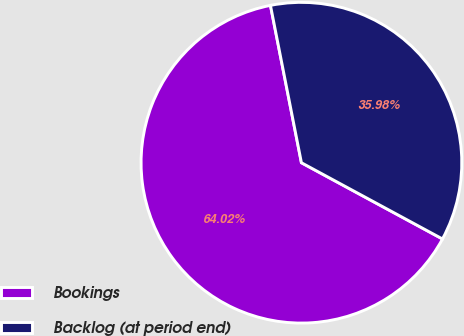Convert chart. <chart><loc_0><loc_0><loc_500><loc_500><pie_chart><fcel>Bookings<fcel>Backlog (at period end)<nl><fcel>64.02%<fcel>35.98%<nl></chart> 